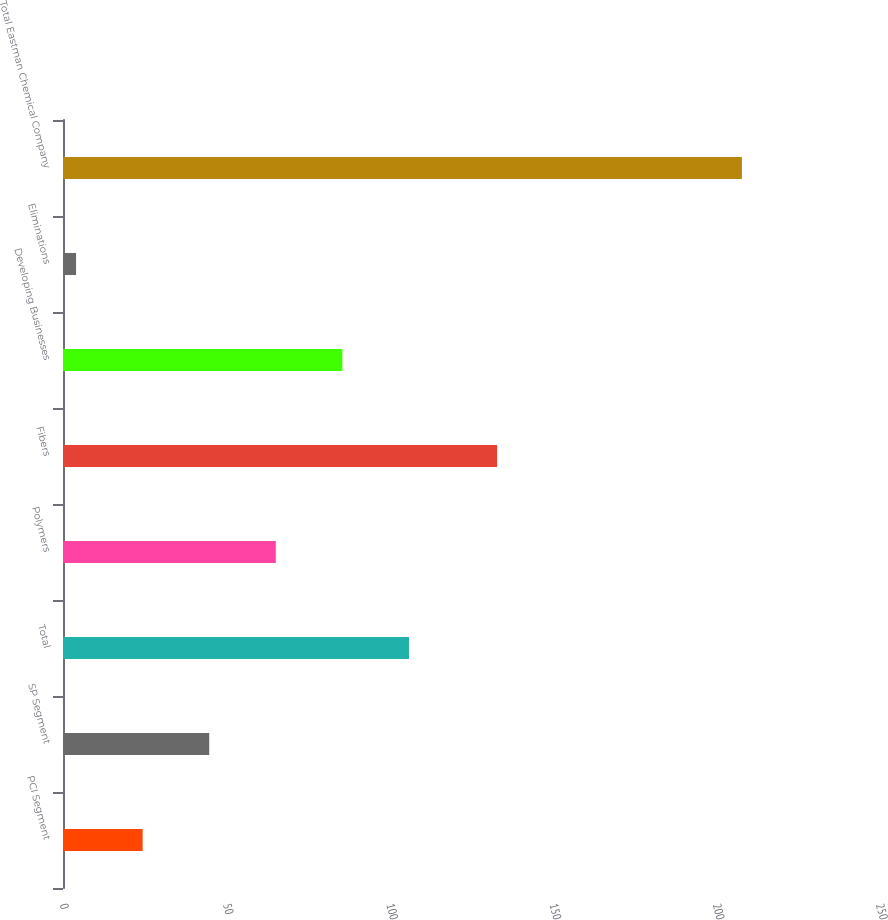Convert chart. <chart><loc_0><loc_0><loc_500><loc_500><bar_chart><fcel>PCI Segment<fcel>SP Segment<fcel>Total<fcel>Polymers<fcel>Fibers<fcel>Developing Businesses<fcel>Eliminations<fcel>Total Eastman Chemical Company<nl><fcel>24.4<fcel>44.8<fcel>106<fcel>65.2<fcel>133<fcel>85.6<fcel>4<fcel>208<nl></chart> 